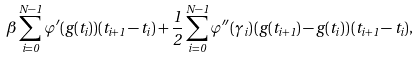<formula> <loc_0><loc_0><loc_500><loc_500>\beta \sum _ { i = 0 } ^ { N - 1 } \varphi ^ { \prime } ( g ( t _ { i } ) ) ( t _ { i + 1 } - t _ { i } ) + \frac { 1 } { 2 } \sum _ { i = 0 } ^ { N - 1 } \varphi ^ { \prime \prime } ( \gamma _ { i } ) \, ( g ( t _ { i + 1 } ) - g ( t _ { i } ) ) \, ( t _ { i + 1 } - t _ { i } ) ,</formula> 